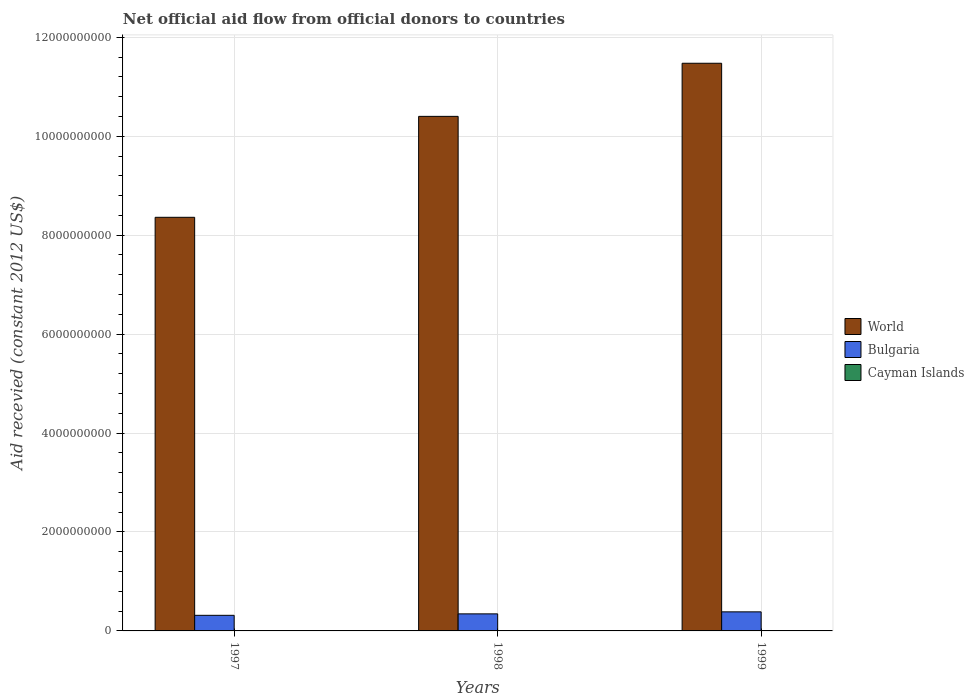How many groups of bars are there?
Your answer should be compact. 3. Are the number of bars per tick equal to the number of legend labels?
Make the answer very short. No. Are the number of bars on each tick of the X-axis equal?
Your response must be concise. No. How many bars are there on the 3rd tick from the left?
Offer a terse response. 3. What is the label of the 1st group of bars from the left?
Provide a succinct answer. 1997. In how many cases, is the number of bars for a given year not equal to the number of legend labels?
Your answer should be compact. 1. What is the total aid received in World in 1997?
Ensure brevity in your answer.  8.36e+09. Across all years, what is the maximum total aid received in World?
Offer a very short reply. 1.15e+1. Across all years, what is the minimum total aid received in Cayman Islands?
Keep it short and to the point. 0. What is the total total aid received in Cayman Islands in the graph?
Offer a very short reply. 5.07e+06. What is the difference between the total aid received in World in 1998 and that in 1999?
Keep it short and to the point. -1.07e+09. What is the difference between the total aid received in World in 1997 and the total aid received in Bulgaria in 1999?
Keep it short and to the point. 7.98e+09. What is the average total aid received in World per year?
Offer a very short reply. 1.01e+1. In the year 1998, what is the difference between the total aid received in Bulgaria and total aid received in World?
Provide a succinct answer. -1.01e+1. What is the ratio of the total aid received in Cayman Islands in 1998 to that in 1999?
Your answer should be very brief. 0.1. Is the total aid received in World in 1997 less than that in 1998?
Make the answer very short. Yes. Is the difference between the total aid received in Bulgaria in 1997 and 1999 greater than the difference between the total aid received in World in 1997 and 1999?
Your answer should be compact. Yes. What is the difference between the highest and the second highest total aid received in Bulgaria?
Your answer should be very brief. 4.06e+07. What is the difference between the highest and the lowest total aid received in Cayman Islands?
Offer a terse response. 4.62e+06. Is the sum of the total aid received in Bulgaria in 1998 and 1999 greater than the maximum total aid received in World across all years?
Offer a terse response. No. How many years are there in the graph?
Make the answer very short. 3. What is the difference between two consecutive major ticks on the Y-axis?
Ensure brevity in your answer.  2.00e+09. Are the values on the major ticks of Y-axis written in scientific E-notation?
Your answer should be very brief. No. Does the graph contain any zero values?
Your answer should be compact. Yes. Does the graph contain grids?
Your response must be concise. Yes. Where does the legend appear in the graph?
Ensure brevity in your answer.  Center right. How many legend labels are there?
Make the answer very short. 3. How are the legend labels stacked?
Your answer should be compact. Vertical. What is the title of the graph?
Your answer should be compact. Net official aid flow from official donors to countries. Does "Russian Federation" appear as one of the legend labels in the graph?
Your answer should be very brief. No. What is the label or title of the Y-axis?
Give a very brief answer. Aid recevied (constant 2012 US$). What is the Aid recevied (constant 2012 US$) of World in 1997?
Give a very brief answer. 8.36e+09. What is the Aid recevied (constant 2012 US$) in Bulgaria in 1997?
Your response must be concise. 3.16e+08. What is the Aid recevied (constant 2012 US$) of World in 1998?
Offer a very short reply. 1.04e+1. What is the Aid recevied (constant 2012 US$) in Bulgaria in 1998?
Your answer should be compact. 3.45e+08. What is the Aid recevied (constant 2012 US$) of World in 1999?
Offer a very short reply. 1.15e+1. What is the Aid recevied (constant 2012 US$) in Bulgaria in 1999?
Provide a short and direct response. 3.85e+08. What is the Aid recevied (constant 2012 US$) of Cayman Islands in 1999?
Your response must be concise. 4.62e+06. Across all years, what is the maximum Aid recevied (constant 2012 US$) of World?
Offer a terse response. 1.15e+1. Across all years, what is the maximum Aid recevied (constant 2012 US$) of Bulgaria?
Offer a terse response. 3.85e+08. Across all years, what is the maximum Aid recevied (constant 2012 US$) of Cayman Islands?
Your answer should be compact. 4.62e+06. Across all years, what is the minimum Aid recevied (constant 2012 US$) in World?
Your response must be concise. 8.36e+09. Across all years, what is the minimum Aid recevied (constant 2012 US$) in Bulgaria?
Your answer should be very brief. 3.16e+08. What is the total Aid recevied (constant 2012 US$) of World in the graph?
Keep it short and to the point. 3.02e+1. What is the total Aid recevied (constant 2012 US$) in Bulgaria in the graph?
Keep it short and to the point. 1.05e+09. What is the total Aid recevied (constant 2012 US$) of Cayman Islands in the graph?
Provide a short and direct response. 5.07e+06. What is the difference between the Aid recevied (constant 2012 US$) of World in 1997 and that in 1998?
Offer a very short reply. -2.04e+09. What is the difference between the Aid recevied (constant 2012 US$) of Bulgaria in 1997 and that in 1998?
Keep it short and to the point. -2.94e+07. What is the difference between the Aid recevied (constant 2012 US$) of World in 1997 and that in 1999?
Ensure brevity in your answer.  -3.11e+09. What is the difference between the Aid recevied (constant 2012 US$) in Bulgaria in 1997 and that in 1999?
Your answer should be very brief. -6.99e+07. What is the difference between the Aid recevied (constant 2012 US$) of World in 1998 and that in 1999?
Give a very brief answer. -1.07e+09. What is the difference between the Aid recevied (constant 2012 US$) of Bulgaria in 1998 and that in 1999?
Offer a very short reply. -4.06e+07. What is the difference between the Aid recevied (constant 2012 US$) of Cayman Islands in 1998 and that in 1999?
Offer a very short reply. -4.17e+06. What is the difference between the Aid recevied (constant 2012 US$) of World in 1997 and the Aid recevied (constant 2012 US$) of Bulgaria in 1998?
Provide a succinct answer. 8.02e+09. What is the difference between the Aid recevied (constant 2012 US$) in World in 1997 and the Aid recevied (constant 2012 US$) in Cayman Islands in 1998?
Offer a very short reply. 8.36e+09. What is the difference between the Aid recevied (constant 2012 US$) in Bulgaria in 1997 and the Aid recevied (constant 2012 US$) in Cayman Islands in 1998?
Your response must be concise. 3.15e+08. What is the difference between the Aid recevied (constant 2012 US$) of World in 1997 and the Aid recevied (constant 2012 US$) of Bulgaria in 1999?
Your answer should be very brief. 7.98e+09. What is the difference between the Aid recevied (constant 2012 US$) in World in 1997 and the Aid recevied (constant 2012 US$) in Cayman Islands in 1999?
Offer a very short reply. 8.36e+09. What is the difference between the Aid recevied (constant 2012 US$) in Bulgaria in 1997 and the Aid recevied (constant 2012 US$) in Cayman Islands in 1999?
Offer a very short reply. 3.11e+08. What is the difference between the Aid recevied (constant 2012 US$) of World in 1998 and the Aid recevied (constant 2012 US$) of Bulgaria in 1999?
Make the answer very short. 1.00e+1. What is the difference between the Aid recevied (constant 2012 US$) of World in 1998 and the Aid recevied (constant 2012 US$) of Cayman Islands in 1999?
Keep it short and to the point. 1.04e+1. What is the difference between the Aid recevied (constant 2012 US$) of Bulgaria in 1998 and the Aid recevied (constant 2012 US$) of Cayman Islands in 1999?
Offer a very short reply. 3.40e+08. What is the average Aid recevied (constant 2012 US$) of World per year?
Your answer should be compact. 1.01e+1. What is the average Aid recevied (constant 2012 US$) in Bulgaria per year?
Provide a short and direct response. 3.49e+08. What is the average Aid recevied (constant 2012 US$) in Cayman Islands per year?
Make the answer very short. 1.69e+06. In the year 1997, what is the difference between the Aid recevied (constant 2012 US$) in World and Aid recevied (constant 2012 US$) in Bulgaria?
Offer a terse response. 8.05e+09. In the year 1998, what is the difference between the Aid recevied (constant 2012 US$) of World and Aid recevied (constant 2012 US$) of Bulgaria?
Provide a succinct answer. 1.01e+1. In the year 1998, what is the difference between the Aid recevied (constant 2012 US$) of World and Aid recevied (constant 2012 US$) of Cayman Islands?
Make the answer very short. 1.04e+1. In the year 1998, what is the difference between the Aid recevied (constant 2012 US$) in Bulgaria and Aid recevied (constant 2012 US$) in Cayman Islands?
Provide a short and direct response. 3.44e+08. In the year 1999, what is the difference between the Aid recevied (constant 2012 US$) in World and Aid recevied (constant 2012 US$) in Bulgaria?
Ensure brevity in your answer.  1.11e+1. In the year 1999, what is the difference between the Aid recevied (constant 2012 US$) of World and Aid recevied (constant 2012 US$) of Cayman Islands?
Ensure brevity in your answer.  1.15e+1. In the year 1999, what is the difference between the Aid recevied (constant 2012 US$) in Bulgaria and Aid recevied (constant 2012 US$) in Cayman Islands?
Your answer should be very brief. 3.81e+08. What is the ratio of the Aid recevied (constant 2012 US$) in World in 1997 to that in 1998?
Your answer should be compact. 0.8. What is the ratio of the Aid recevied (constant 2012 US$) in Bulgaria in 1997 to that in 1998?
Ensure brevity in your answer.  0.91. What is the ratio of the Aid recevied (constant 2012 US$) of World in 1997 to that in 1999?
Offer a terse response. 0.73. What is the ratio of the Aid recevied (constant 2012 US$) in Bulgaria in 1997 to that in 1999?
Your answer should be very brief. 0.82. What is the ratio of the Aid recevied (constant 2012 US$) in World in 1998 to that in 1999?
Offer a very short reply. 0.91. What is the ratio of the Aid recevied (constant 2012 US$) of Bulgaria in 1998 to that in 1999?
Your answer should be compact. 0.89. What is the ratio of the Aid recevied (constant 2012 US$) of Cayman Islands in 1998 to that in 1999?
Offer a terse response. 0.1. What is the difference between the highest and the second highest Aid recevied (constant 2012 US$) in World?
Offer a terse response. 1.07e+09. What is the difference between the highest and the second highest Aid recevied (constant 2012 US$) of Bulgaria?
Give a very brief answer. 4.06e+07. What is the difference between the highest and the lowest Aid recevied (constant 2012 US$) of World?
Ensure brevity in your answer.  3.11e+09. What is the difference between the highest and the lowest Aid recevied (constant 2012 US$) of Bulgaria?
Your answer should be very brief. 6.99e+07. What is the difference between the highest and the lowest Aid recevied (constant 2012 US$) in Cayman Islands?
Give a very brief answer. 4.62e+06. 